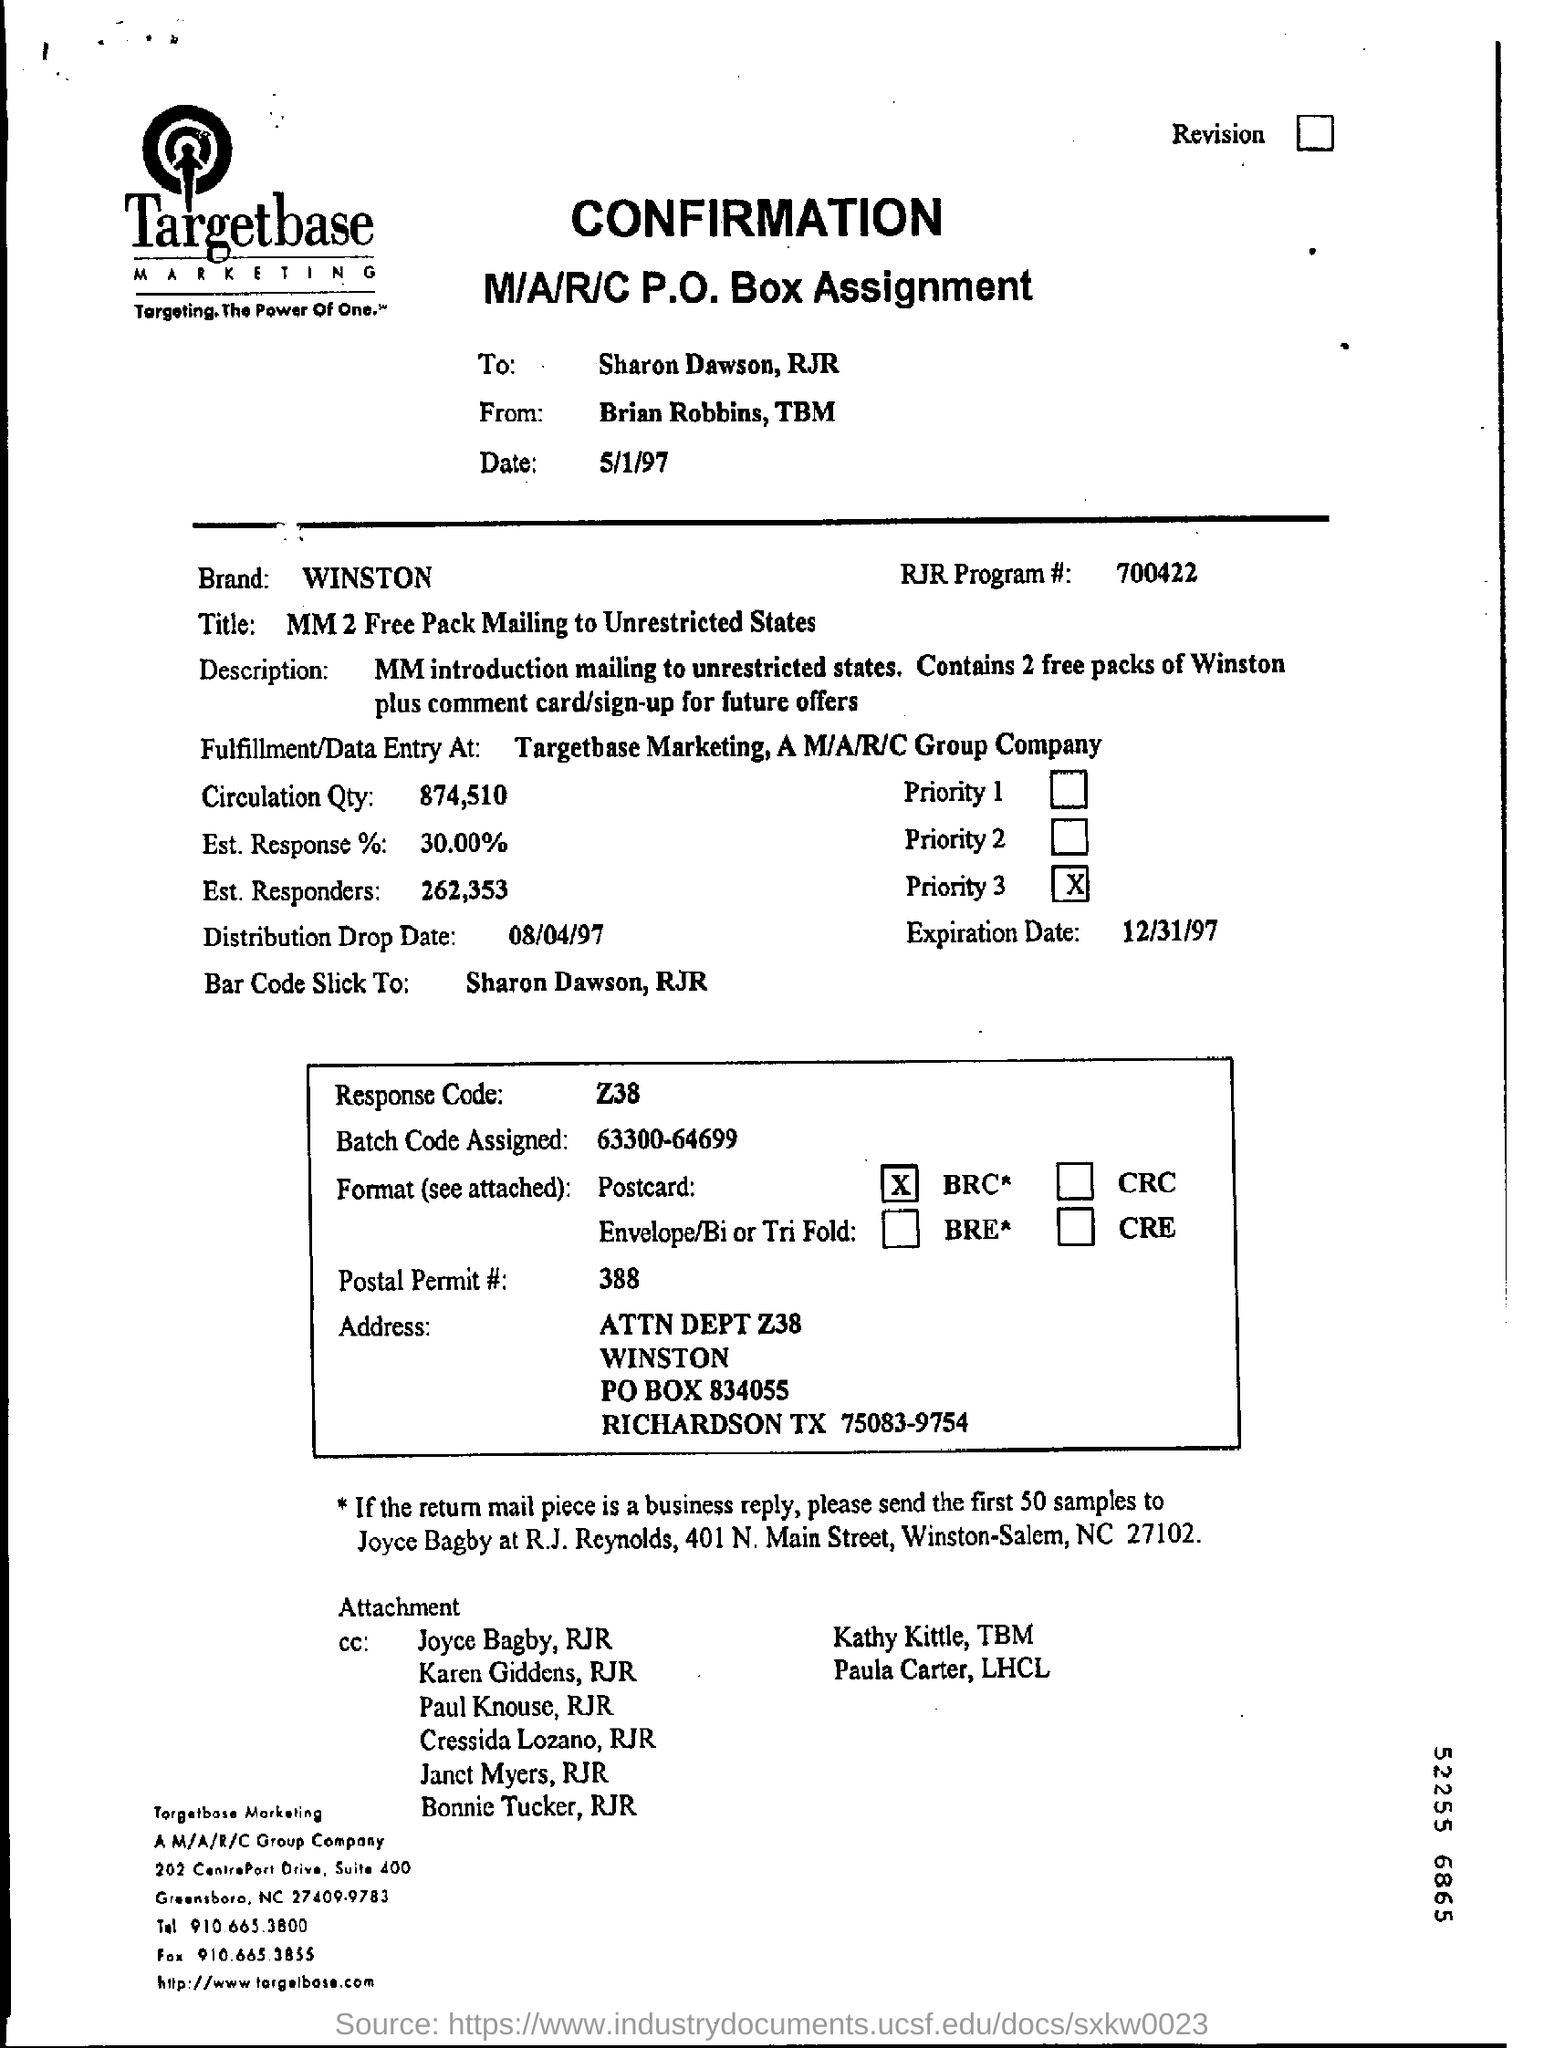What is the rjr program #?
Your response must be concise. 700422. In which state is am/a/r/c group company located ?
Offer a terse response. NC. What is the name of the brand?
Provide a succinct answer. WINSTON. How much is the circulation qty?
Give a very brief answer. 874,510. What is the response code ?
Provide a succinct answer. Z38. What is the postal permit #?
Offer a terse response. 388. How many samples must be sent to joyce bagby?
Offer a very short reply. 50. Mention the expiration date ?
Your answer should be very brief. 12/31/97. 